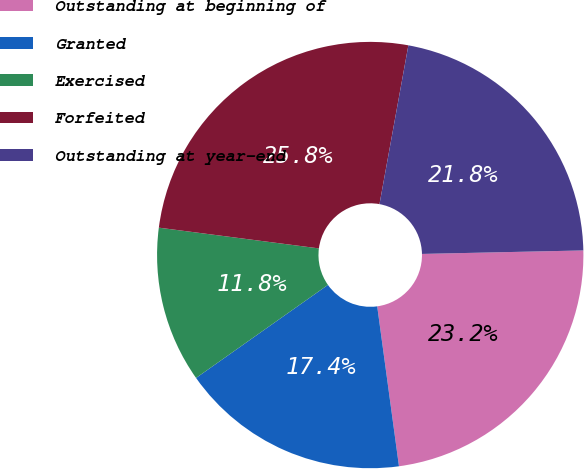<chart> <loc_0><loc_0><loc_500><loc_500><pie_chart><fcel>Outstanding at beginning of<fcel>Granted<fcel>Exercised<fcel>Forfeited<fcel>Outstanding at year-end<nl><fcel>23.19%<fcel>17.37%<fcel>11.83%<fcel>25.81%<fcel>21.79%<nl></chart> 